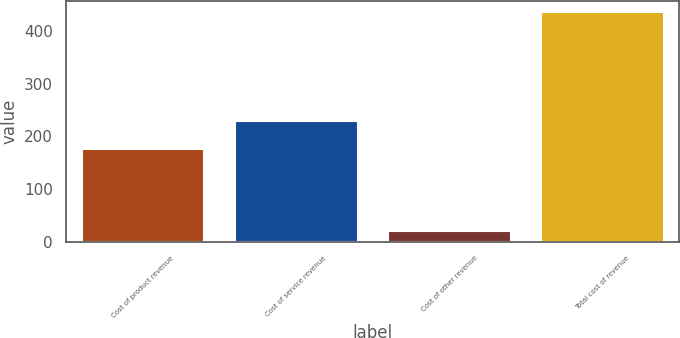Convert chart. <chart><loc_0><loc_0><loc_500><loc_500><bar_chart><fcel>Cost of product revenue<fcel>Cost of service revenue<fcel>Cost of other revenue<fcel>Total cost of revenue<nl><fcel>176.2<fcel>229.4<fcel>20.6<fcel>436.1<nl></chart> 